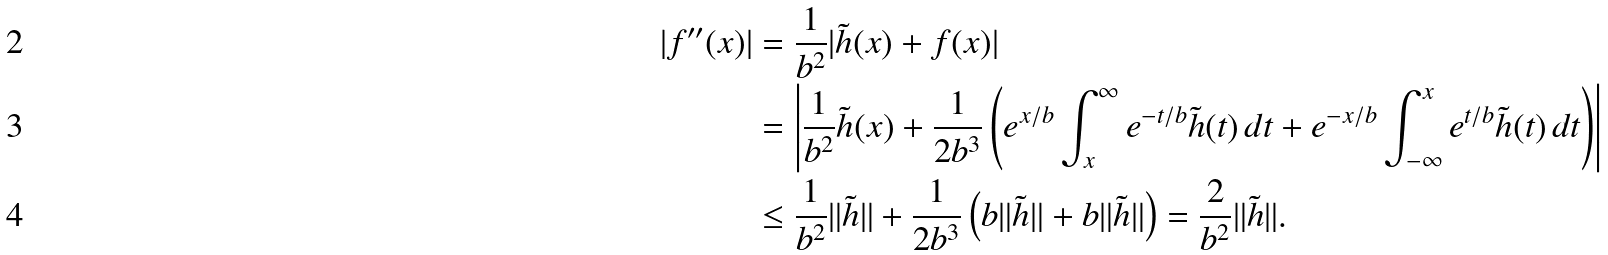<formula> <loc_0><loc_0><loc_500><loc_500>| f ^ { \prime \prime } ( x ) | & = \frac { 1 } { b ^ { 2 } } | \tilde { h } ( x ) + f ( x ) | \\ & = \left | \frac { 1 } { b ^ { 2 } } \tilde { h } ( x ) + \frac { 1 } { 2 b ^ { 3 } } \left ( e ^ { x / b } \int _ { x } ^ { \infty } e ^ { - t / b } \tilde { h } ( t ) \, d t + e ^ { - x / b } \int _ { - \infty } ^ { x } e ^ { t / b } \tilde { h } ( t ) \, d t \right ) \right | \\ & \leq \frac { 1 } { b ^ { 2 } } \| \tilde { h } \| + \frac { 1 } { 2 b ^ { 3 } } \left ( b \| \tilde { h } \| + b \| \tilde { h } \| \right ) = \frac { 2 } { b ^ { 2 } } \| \tilde { h } \| .</formula> 